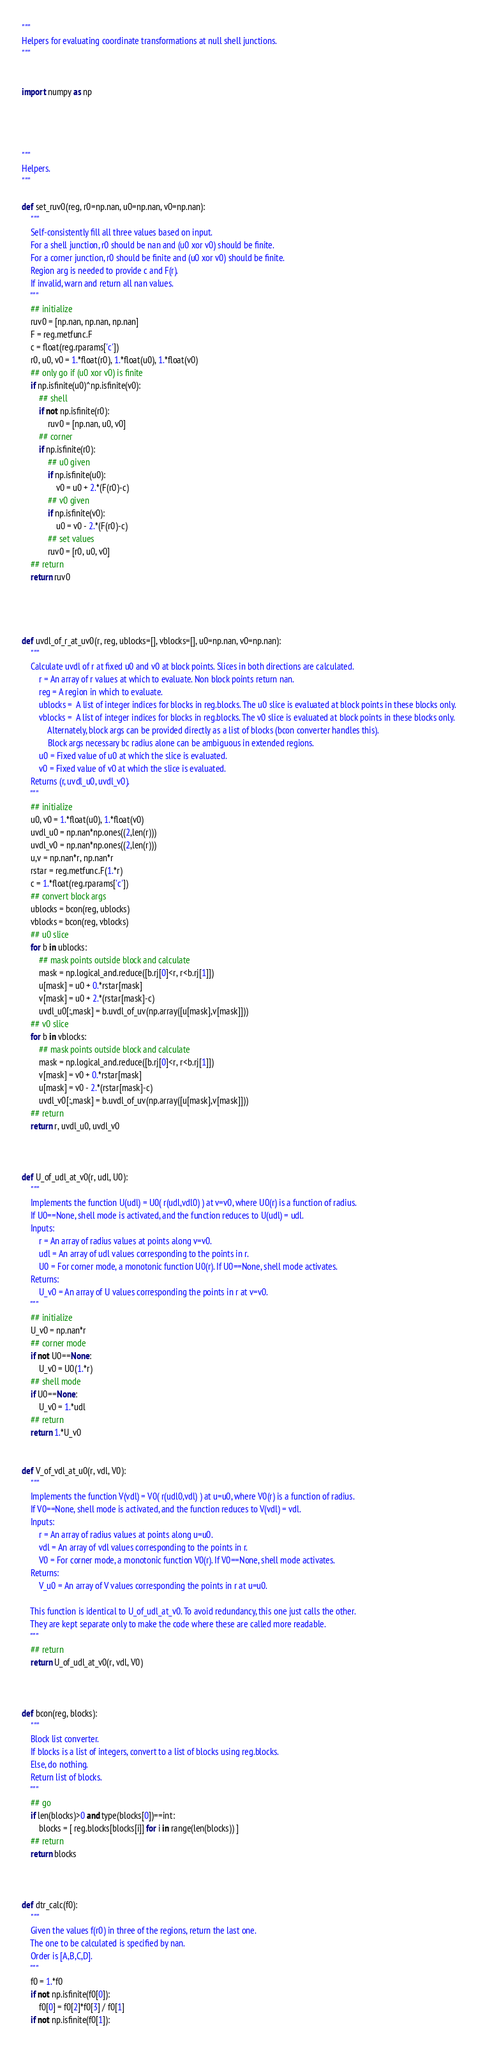<code> <loc_0><loc_0><loc_500><loc_500><_Python_>
"""
Helpers for evaluating coordinate transformations at null shell junctions.
"""


import numpy as np




"""
Helpers.
"""

def set_ruv0(reg, r0=np.nan, u0=np.nan, v0=np.nan):
	"""
	Self-consistently fill all three values based on input.
	For a shell junction, r0 should be nan and (u0 xor v0) should be finite.
	For a corner junction, r0 should be finite and (u0 xor v0) should be finite.
	Region arg is needed to provide c and F(r).
	If invalid, warn and return all nan values.
	"""
	## initialize
	ruv0 = [np.nan, np.nan, np.nan]
	F = reg.metfunc.F
	c = float(reg.rparams['c'])
	r0, u0, v0 = 1.*float(r0), 1.*float(u0), 1.*float(v0)
	## only go if (u0 xor v0) is finite
	if np.isfinite(u0)^np.isfinite(v0):
		## shell
		if not np.isfinite(r0):
			ruv0 = [np.nan, u0, v0]
		## corner
		if np.isfinite(r0):
			## u0 given
			if np.isfinite(u0):
				v0 = u0 + 2.*(F(r0)-c)
			## v0 given
			if np.isfinite(v0):
				u0 = v0 - 2.*(F(r0)-c)	
			## set values
			ruv0 = [r0, u0, v0]
	## return
	return ruv0




def uvdl_of_r_at_uv0(r, reg, ublocks=[], vblocks=[], u0=np.nan, v0=np.nan):
	"""
	Calculate uvdl of r at fixed u0 and v0 at block points. Slices in both directions are calculated.
		r = An array of r values at which to evaluate. Non block points return nan.
		reg = A region in which to evaluate.
		ublocks =  A list of integer indices for blocks in reg.blocks. The u0 slice is evaluated at block points in these blocks only.
		vblocks =  A list of integer indices for blocks in reg.blocks. The v0 slice is evaluated at block points in these blocks only.
			Alternately, block args can be provided directly as a list of blocks (bcon converter handles this).
			Block args necessary bc radius alone can be ambiguous in extended regions. 
		u0 = Fixed value of u0 at which the slice is evaluated.
		v0 = Fixed value of v0 at which the slice is evaluated.
	Returns (r, uvdl_u0, uvdl_v0).
	"""
	## initialize
	u0, v0 = 1.*float(u0), 1.*float(v0)
	uvdl_u0 = np.nan*np.ones((2,len(r)))
	uvdl_v0 = np.nan*np.ones((2,len(r)))
	u,v = np.nan*r, np.nan*r
	rstar = reg.metfunc.F(1.*r)
	c = 1.*float(reg.rparams['c'])
	## convert block args
	ublocks = bcon(reg, ublocks)
	vblocks = bcon(reg, vblocks)
	## u0 slice
	for b in ublocks:
		## mask points outside block and calculate
		mask = np.logical_and.reduce([b.rj[0]<r, r<b.rj[1]])
		u[mask] = u0 + 0.*rstar[mask]
		v[mask] = u0 + 2.*(rstar[mask]-c)
		uvdl_u0[:,mask] = b.uvdl_of_uv(np.array([u[mask],v[mask]]))
	## v0 slice
	for b in vblocks:
		## mask points outside block and calculate
		mask = np.logical_and.reduce([b.rj[0]<r, r<b.rj[1]])
		v[mask] = v0 + 0.*rstar[mask]
		u[mask] = v0 - 2.*(rstar[mask]-c)
		uvdl_v0[:,mask] = b.uvdl_of_uv(np.array([u[mask],v[mask]]))
	## return
	return r, uvdl_u0, uvdl_v0



def U_of_udl_at_v0(r, udl, U0):
	"""
	Implements the function U(udl) = U0( r(udl,vdl0) ) at v=v0, where U0(r) is a function of radius.
	If U0==None, shell mode is activated, and the function reduces to U(udl) = udl.
	Inputs:
		r = An array of radius values at points along v=v0.
		udl = An array of udl values corresponding to the points in r.
		U0 = For corner mode, a monotonic function U0(r). If U0==None, shell mode activates.
	Returns:
		U_v0 = An array of U values corresponding the points in r at v=v0.
	"""
	## initialize
	U_v0 = np.nan*r
	## corner mode
	if not U0==None:
		U_v0 = U0(1.*r)
	## shell mode
	if U0==None:
		U_v0 = 1.*udl
	## return
	return 1.*U_v0


def V_of_vdl_at_u0(r, vdl, V0):
	"""
	Implements the function V(vdl) = V0( r(udl0,vdl) ) at u=u0, where V0(r) is a function of radius.
	If V0==None, shell mode is activated, and the function reduces to V(vdl) = vdl.
	Inputs:
		r = An array of radius values at points along u=u0.
		vdl = An array of vdl values corresponding to the points in r.
		V0 = For corner mode, a monotonic function V0(r). If V0==None, shell mode activates.
	Returns:
		V_u0 = An array of V values corresponding the points in r at u=u0.
	
	This function is identical to U_of_udl_at_v0. To avoid redundancy, this one just calls the other.
	They are kept separate only to make the code where these are called more readable.
	"""
	## return
	return U_of_udl_at_v0(r, vdl, V0)



def bcon(reg, blocks):
	"""
	Block list converter.
	If blocks is a list of integers, convert to a list of blocks using reg.blocks.
	Else, do nothing.
	Return list of blocks.
	"""
	## go
	if len(blocks)>0 and type(blocks[0])==int:
		blocks = [ reg.blocks[blocks[i]] for i in range(len(blocks)) ]
	## return
	return blocks



def dtr_calc(f0):
	"""
	Given the values f(r0) in three of the regions, return the last one.
	The one to be calculated is specified by nan. 
	Order is [A,B,C,D].
	"""
	f0 = 1.*f0
	if not np.isfinite(f0[0]):
		f0[0] = f0[2]*f0[3] / f0[1]
	if not np.isfinite(f0[1]):</code> 